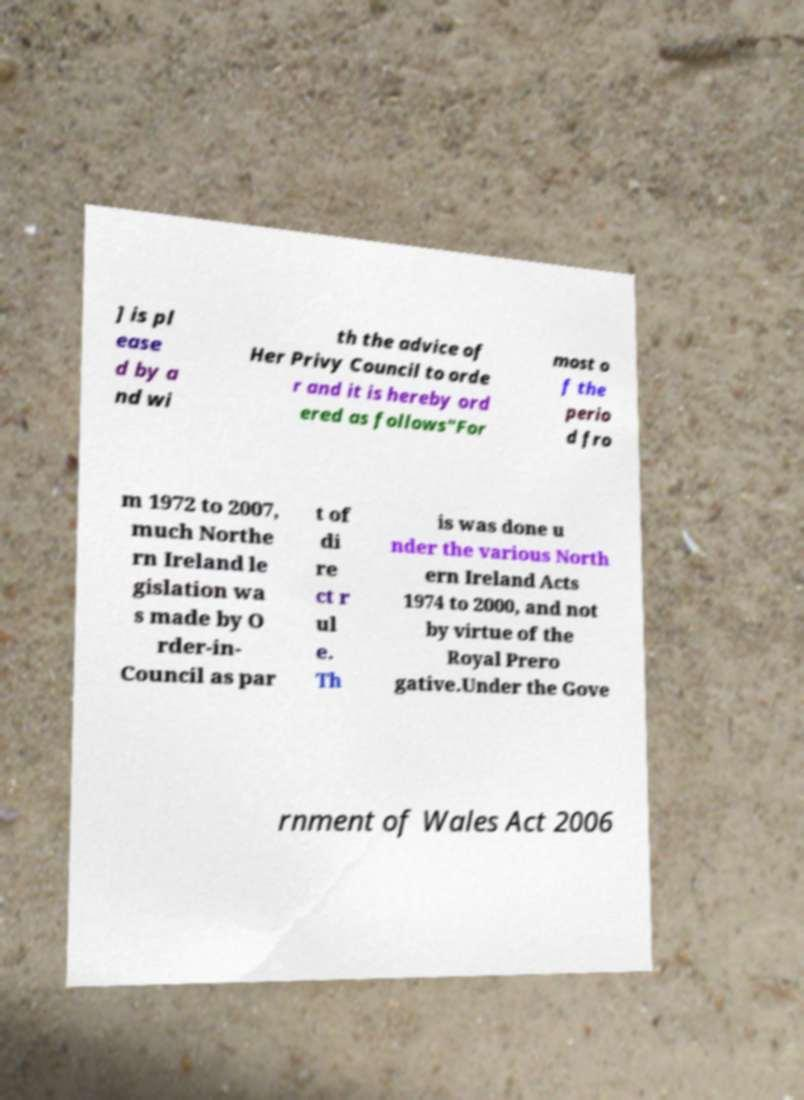What messages or text are displayed in this image? I need them in a readable, typed format. ] is pl ease d by a nd wi th the advice of Her Privy Council to orde r and it is hereby ord ered as follows"For most o f the perio d fro m 1972 to 2007, much Northe rn Ireland le gislation wa s made by O rder-in- Council as par t of di re ct r ul e. Th is was done u nder the various North ern Ireland Acts 1974 to 2000, and not by virtue of the Royal Prero gative.Under the Gove rnment of Wales Act 2006 